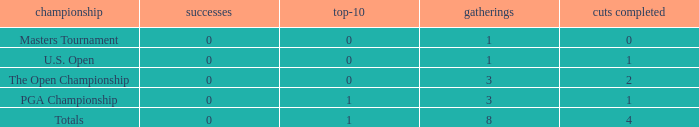For events with values of exactly 1, and 0 cuts made, what is the fewest number of top-10s? 0.0. 